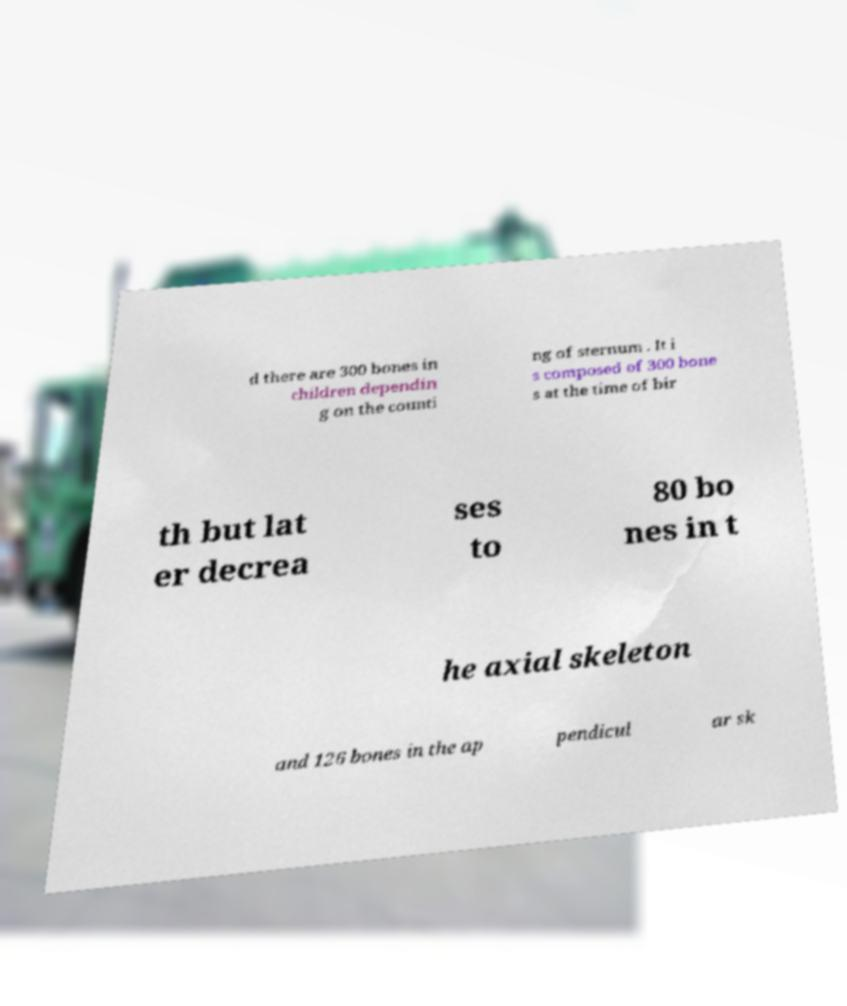For documentation purposes, I need the text within this image transcribed. Could you provide that? d there are 300 bones in children dependin g on the counti ng of sternum . It i s composed of 300 bone s at the time of bir th but lat er decrea ses to 80 bo nes in t he axial skeleton and 126 bones in the ap pendicul ar sk 